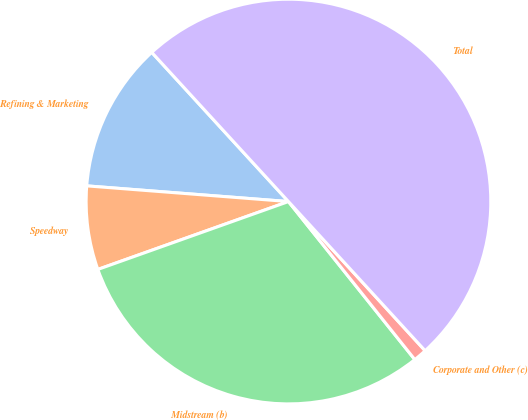Convert chart. <chart><loc_0><loc_0><loc_500><loc_500><pie_chart><fcel>Refining & Marketing<fcel>Speedway<fcel>Midstream (b)<fcel>Corporate and Other (c)<fcel>Total<nl><fcel>11.96%<fcel>6.68%<fcel>30.29%<fcel>1.07%<fcel>50.0%<nl></chart> 